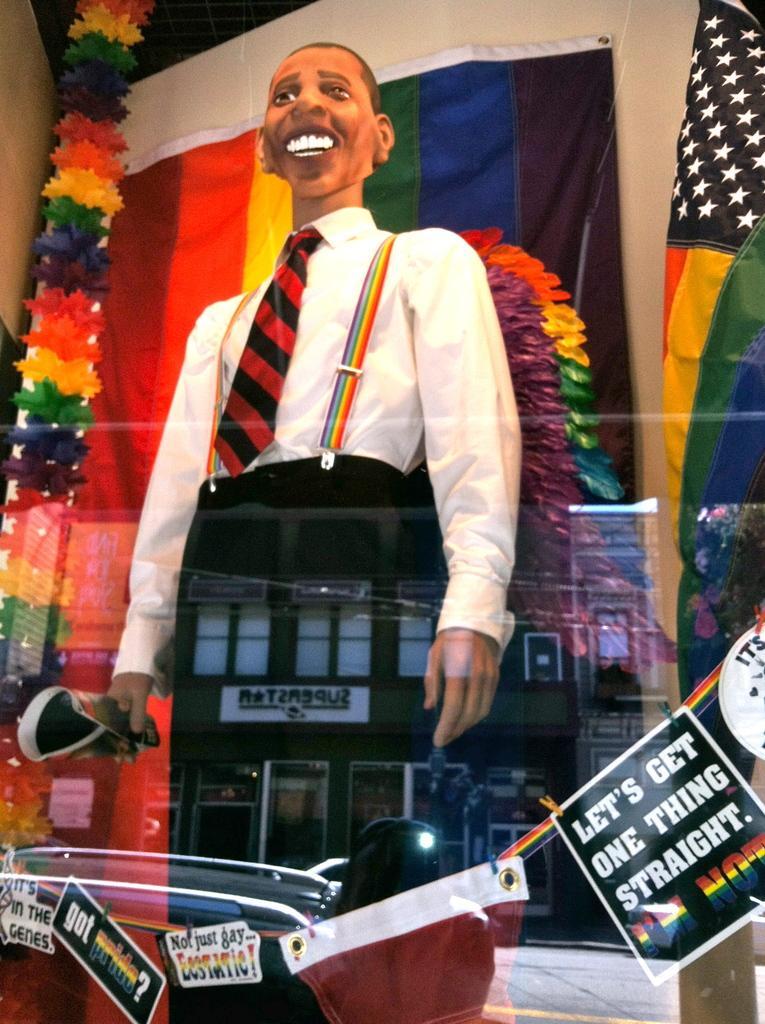Describe this image in one or two sentences. In this picture there is a statue of a man holding a poster. We can see posters, cloth and objects. In the background of the image we can see flags, wall and decorative items. 